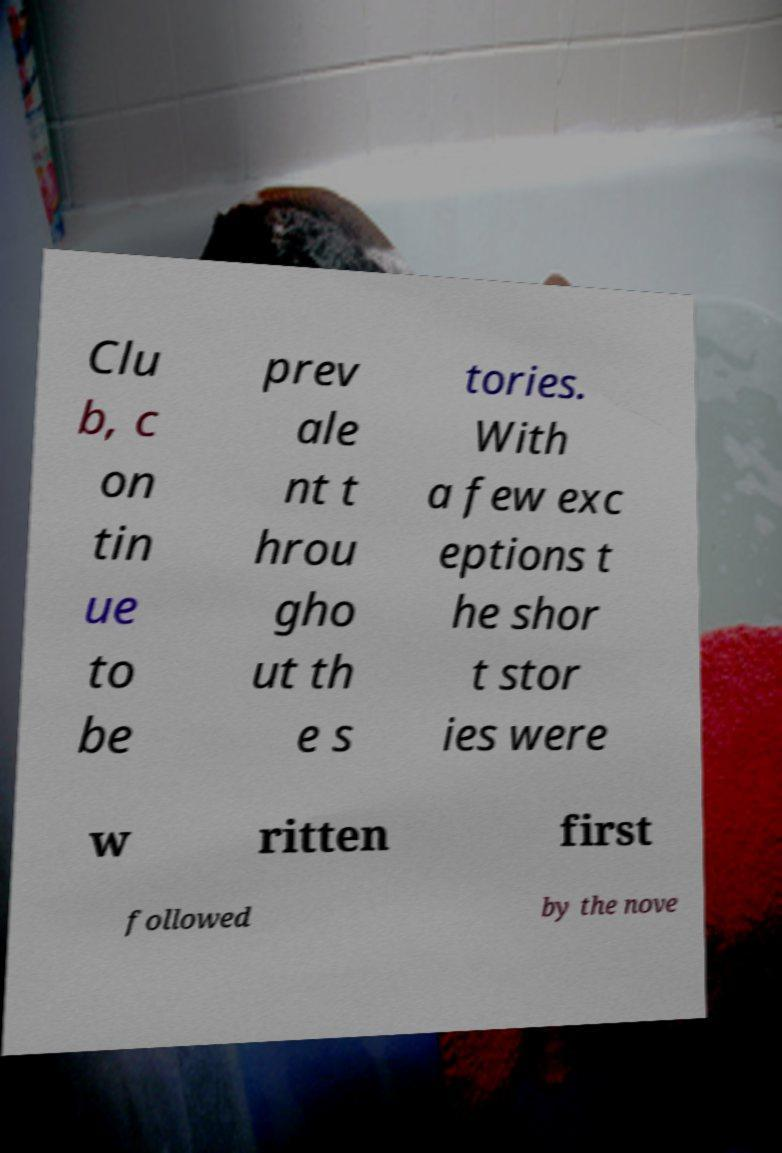Please identify and transcribe the text found in this image. Clu b, c on tin ue to be prev ale nt t hrou gho ut th e s tories. With a few exc eptions t he shor t stor ies were w ritten first followed by the nove 